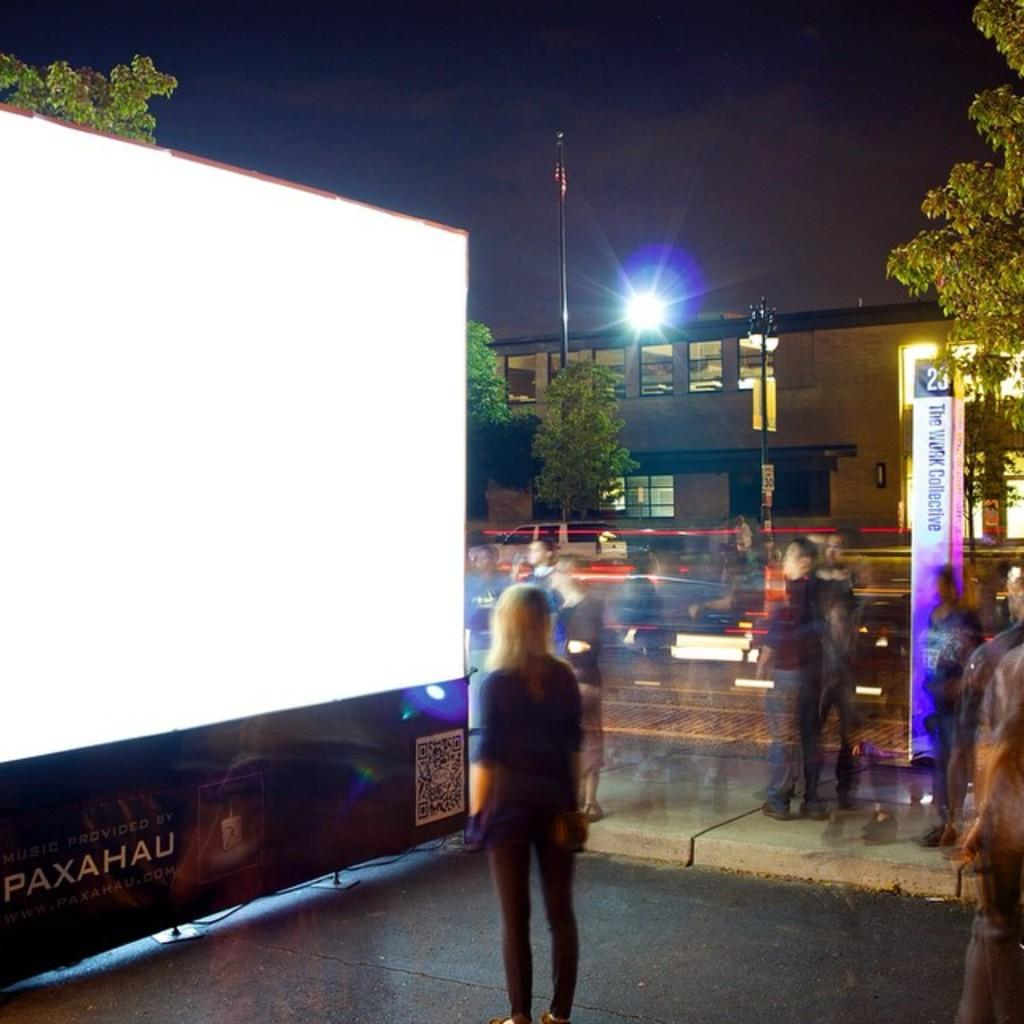What are the persons in the image doing? The persons in the image are standing in front of a digital screen and watching it. What can be seen in the background of the image? There are trees, a street light, a building, and a flag pole with a flag in the background of the image. What type of metal is the queen using to create humor in the image? There is no queen or metal present in the image, and therefore no such activity can be observed. 